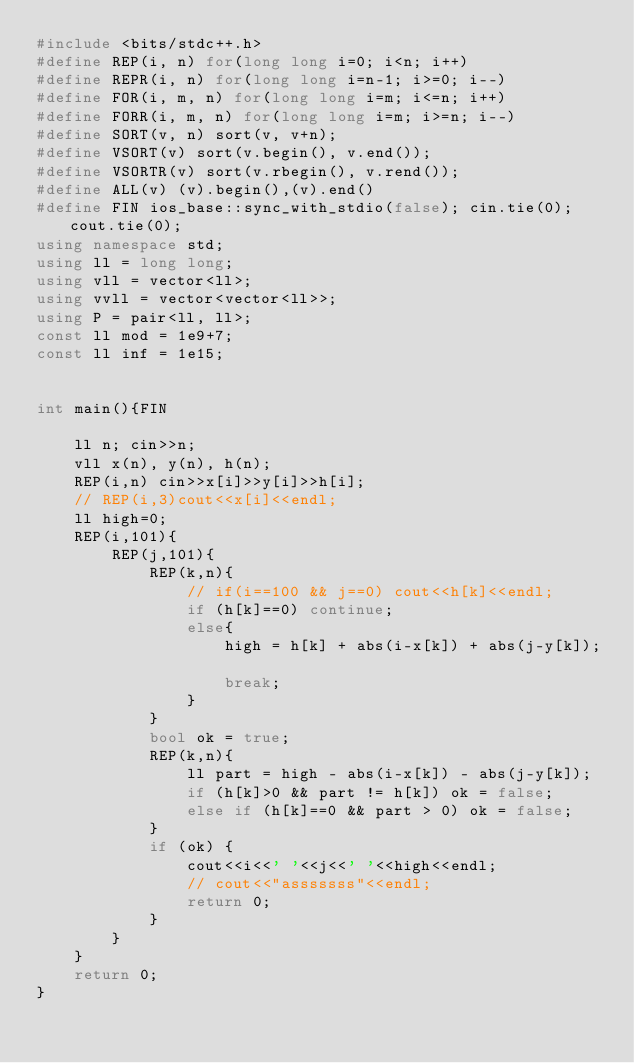Convert code to text. <code><loc_0><loc_0><loc_500><loc_500><_C++_>#include <bits/stdc++.h>
#define REP(i, n) for(long long i=0; i<n; i++)
#define REPR(i, n) for(long long i=n-1; i>=0; i--)
#define FOR(i, m, n) for(long long i=m; i<=n; i++)
#define FORR(i, m, n) for(long long i=m; i>=n; i--)
#define SORT(v, n) sort(v, v+n);
#define VSORT(v) sort(v.begin(), v.end());
#define VSORTR(v) sort(v.rbegin(), v.rend());
#define ALL(v) (v).begin(),(v).end()
#define FIN ios_base::sync_with_stdio(false); cin.tie(0); cout.tie(0);
using namespace std;
using ll = long long;
using vll = vector<ll>;
using vvll = vector<vector<ll>>;
using P = pair<ll, ll>;
const ll mod = 1e9+7;
const ll inf = 1e15;


int main(){FIN

    ll n; cin>>n;
    vll x(n), y(n), h(n);
    REP(i,n) cin>>x[i]>>y[i]>>h[i];
    // REP(i,3)cout<<x[i]<<endl;
    ll high=0;
    REP(i,101){
        REP(j,101){
            REP(k,n){
                // if(i==100 && j==0) cout<<h[k]<<endl;
                if (h[k]==0) continue;
                else{
                    high = h[k] + abs(i-x[k]) + abs(j-y[k]);
                    
                    break;
                }
            }
            bool ok = true;
            REP(k,n){
                ll part = high - abs(i-x[k]) - abs(j-y[k]);
                if (h[k]>0 && part != h[k]) ok = false;
                else if (h[k]==0 && part > 0) ok = false;
            }
            if (ok) {
                cout<<i<<' '<<j<<' '<<high<<endl;
                // cout<<"asssssss"<<endl;
                return 0;
            }
        }
    }
    return 0;
}</code> 